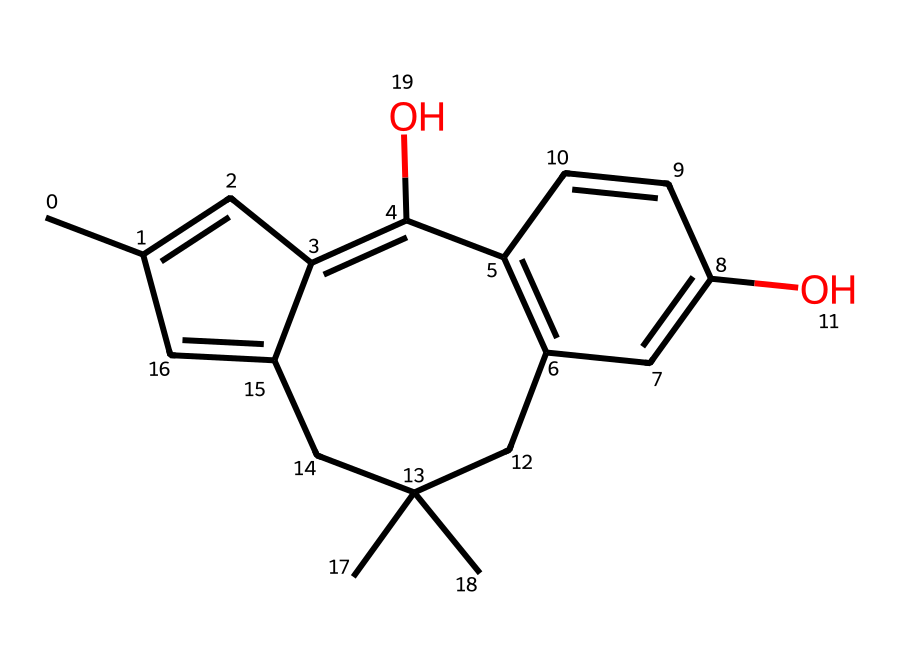What is the molecular formula of this compound? The SMILES representation indicates the number of carbon (C), hydrogen (H), and oxygen (O) atoms in the structure. Counting the elements, we find 21 carbon, 30 hydrogen, and 2 oxygen atoms. Therefore, the molecular formula can be written as C21H30O2.
Answer: C21H30O2 How many rings are present in this structure? The structure of the compound can be analyzed for rings by counting the closed loops formed by the bonds. In this particular structure, there are two distinct rings present.
Answer: 2 What functional groups are identified in this chemical? By examining the structure closely, the SMILES indicates the presence of hydroxyl (-OH) groups linked to the carbon atoms, marking the locations of two phenolic groups. Therefore, the functional groups are hydroxyl groups.
Answer: hydroxyl groups Does this chemical contain any double bonds? The presence of double bonds can be inferred from the unsaturation indicated by the structure. Analyzing the carbon-carbon connections in the compound reveals multiple double bonds within the cyclic structures.
Answer: yes What is the primary psychoactive compound represented? This chemical, based on its structure and known properties, is identified as tetrahydrocannabinol (THC), which is the main psychoactive ingredient in cannabis responsible for its effects.
Answer: tetrahydrocannabinol (THC) How many oxygen atoms are present in this molecule? The SMILES representation shows the count of oxygen atoms directly in the molecular structure. Upon closer inspection, it can be determined that there are exactly two oxygen atoms present.
Answer: 2 What type of chemical is this, specifically? Based on its pharmacological properties and structure, this compound is classified as a cannabinoid; these are compounds that act on cannabinoid receptors in the brain.
Answer: cannabinoid 